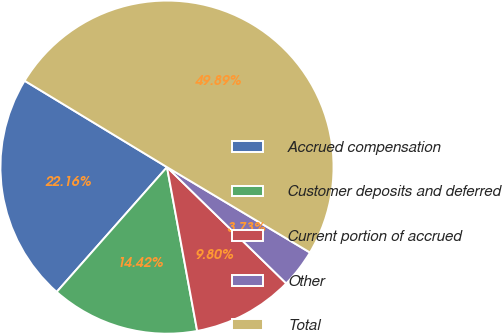Convert chart to OTSL. <chart><loc_0><loc_0><loc_500><loc_500><pie_chart><fcel>Accrued compensation<fcel>Customer deposits and deferred<fcel>Current portion of accrued<fcel>Other<fcel>Total<nl><fcel>22.16%<fcel>14.42%<fcel>9.8%<fcel>3.73%<fcel>49.89%<nl></chart> 